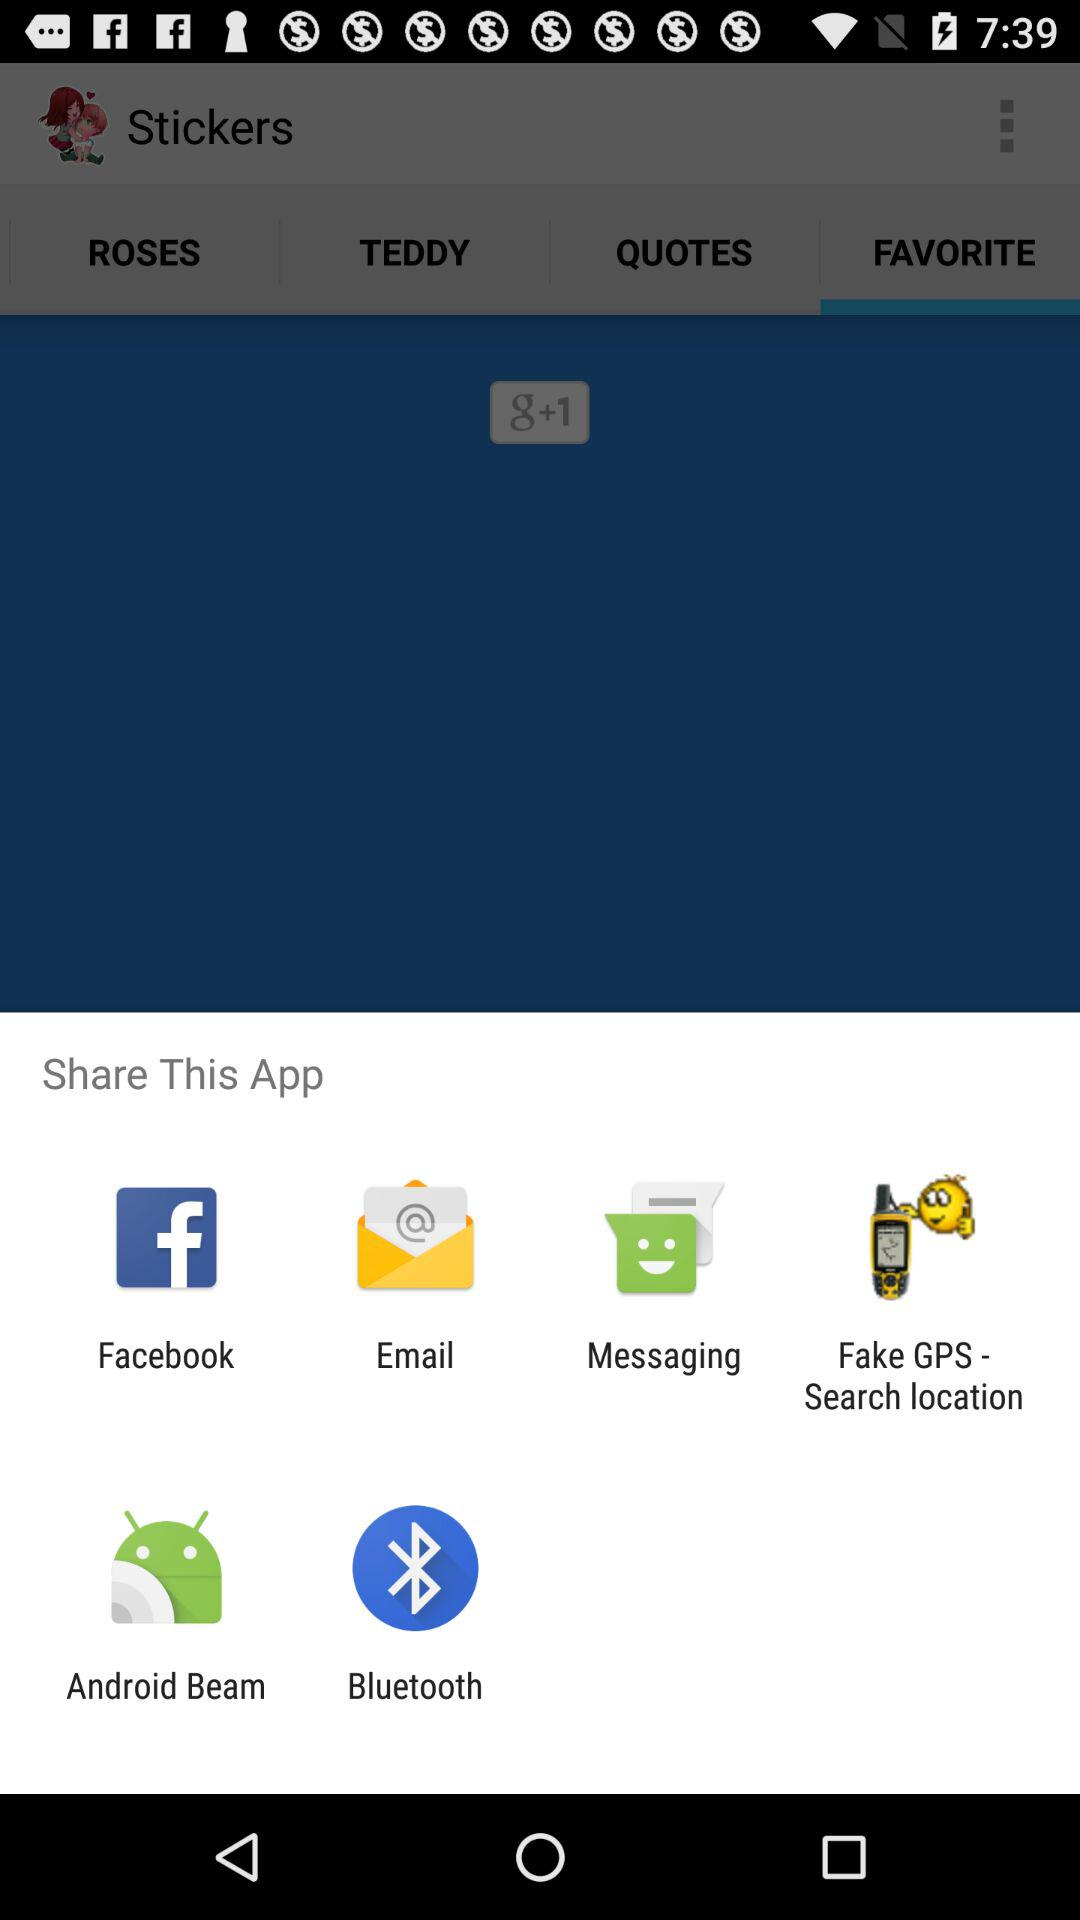Which quotes are available?
When the provided information is insufficient, respond with <no answer>. <no answer> 